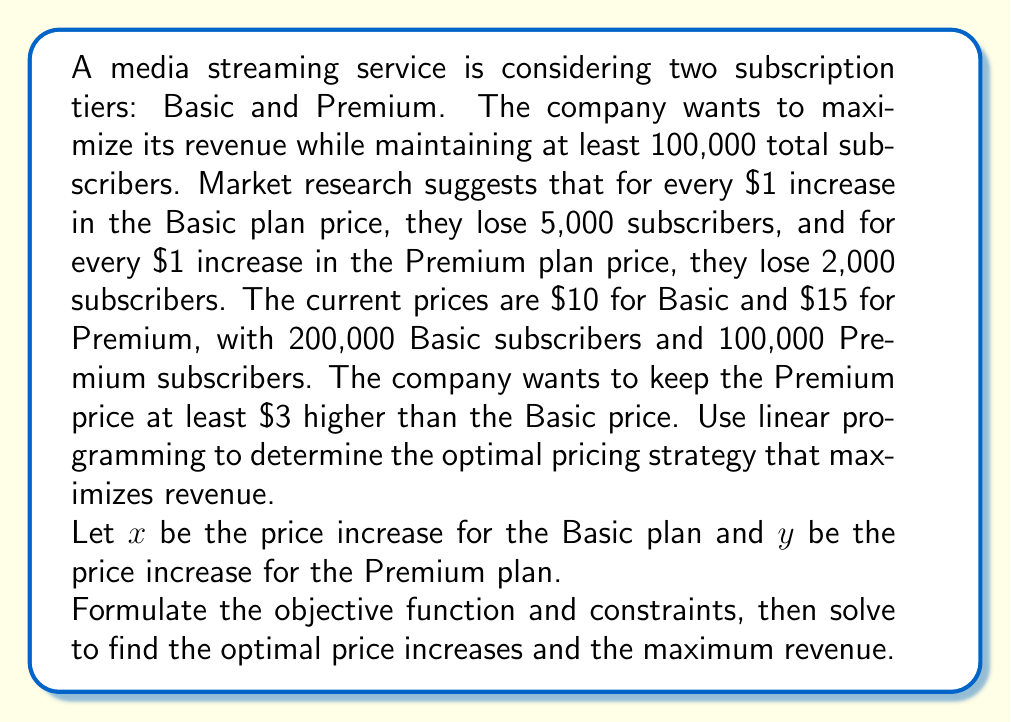Help me with this question. Let's approach this step-by-step:

1. Define variables:
   $x$ = price increase for Basic plan
   $y$ = price increase for Premium plan

2. Objective function (Revenue):
   Revenue = (Basic price × Basic subscribers) + (Premium price × Premium subscribers)
   $R = (10+x)(200000-5000x) + (15+y)(100000-2000y)$

3. Constraints:
   a. Total subscribers ≥ 100,000:
      $(200000-5000x) + (100000-2000y) \geq 100000$
      $200000 - 5000x + 100000 - 2000y \geq 100000$
      $300000 - 5000x - 2000y \geq 100000$
      $-5000x - 2000y \geq -200000$

   b. Premium price at least $3 higher than Basic:
      $(15+y) - (10+x) \geq 3$
      $y - x \geq -2$

   c. Non-negativity:
      $x \geq 0$, $y \geq 0$

4. Simplify the objective function:
   $R = (2000000 - 50000x + 10x^2) + (1500000 - 30000y + 15y^2)$
   $R = 3500000 - 50000x + 10x^2 - 30000y + 15y^2$

5. To maximize R, we need to find the partial derivatives and set them to zero:
   $\frac{\partial R}{\partial x} = -50000 + 20x = 0$
   $\frac{\partial R}{\partial y} = -30000 + 30y = 0$

6. Solve these equations:
   $x = 2500$
   $y = 1000$

7. Check if these values satisfy the constraints:
   a. $-5000(2500) - 2000(1000) = -14500000 \not\geq -200000$ (not satisfied)
   b. $1000 - 2500 = -1500 \geq -2$ (satisfied)
   c. $2500 \geq 0$, $1000 \geq 0$ (satisfied)

8. Since the unconstrained maximum doesn't satisfy all constraints, we need to find the maximum along the binding constraint:
   $-5000x - 2000y = -200000$

9. Substitute this into the objective function:
   $R = 3500000 - 50000x + 10x^2 - 30000y + 15y^2$
   $y = 100 - 2.5x$
   $R = 3500000 - 50000x + 10x^2 - 30000(100 - 2.5x) + 15(100 - 2.5x)^2$
   $R = 3500000 - 50000x + 10x^2 - 3000000 + 75000x + 150000 - 7500x + 93.75x^2$
   $R = 650000 + 17500x + 103.75x^2$

10. Maximize this new function:
    $\frac{dR}{dx} = 17500 + 207.5x = 0$
    $x = -84.34$

11. Since $x$ cannot be negative, the maximum must occur at one of the endpoints. Let's check $x = 0$ and the maximum possible $x$ (when $y = 0$):
    At $x = 0$: $y = 100$, $R = 3500000$
    At $x = 40$ (when $y = 0$): $R = 3650000$

Therefore, the optimal solution is to increase the Basic plan price by $40 and keep the Premium plan price unchanged.
Answer: Increase Basic plan by $40, keep Premium plan unchanged. Maximum revenue: $3,650,000. 